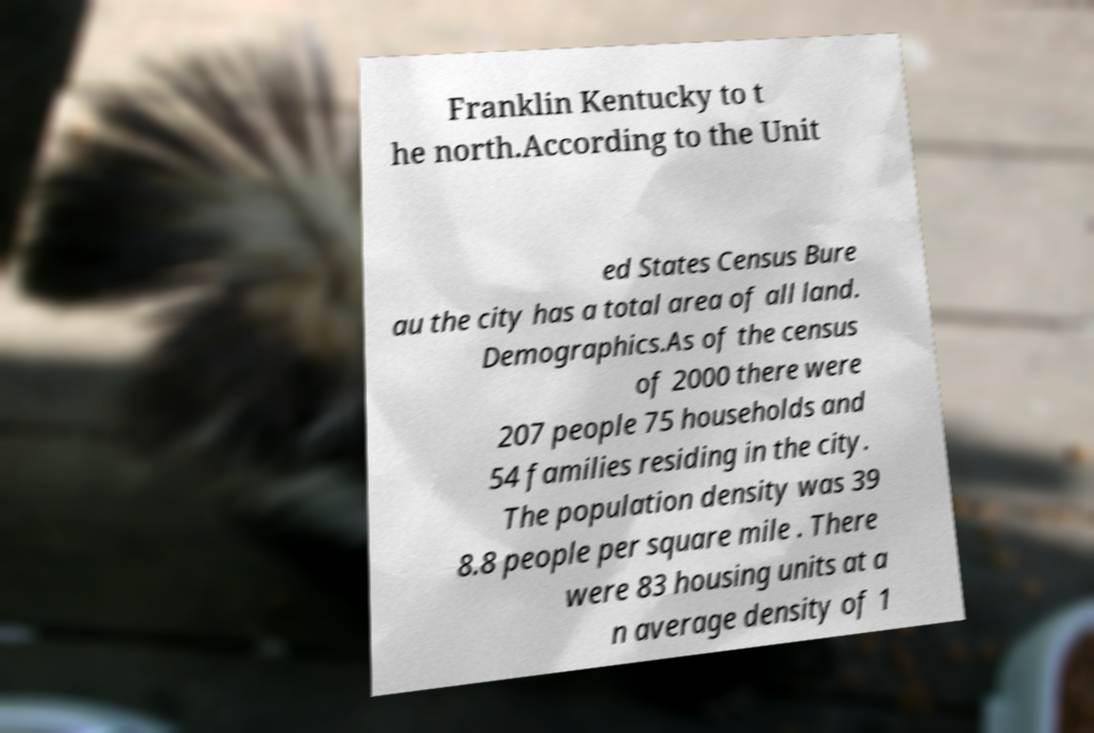There's text embedded in this image that I need extracted. Can you transcribe it verbatim? Franklin Kentucky to t he north.According to the Unit ed States Census Bure au the city has a total area of all land. Demographics.As of the census of 2000 there were 207 people 75 households and 54 families residing in the city. The population density was 39 8.8 people per square mile . There were 83 housing units at a n average density of 1 